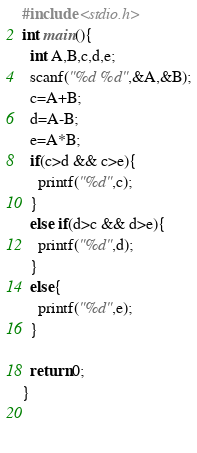Convert code to text. <code><loc_0><loc_0><loc_500><loc_500><_C_>#include <stdio.h>
int main(){
  int A,B,c,d,e;
  scanf("%d %d",&A,&B);
  c=A+B;
  d=A-B;
  e=A*B;
  if(c>d && c>e){
    printf("%d",c);
  }
  else if(d>c && d>e){
    printf("%d",d);
  }
  else{
    printf("%d",e);
  }
  
  return 0;
}
  
  
</code> 